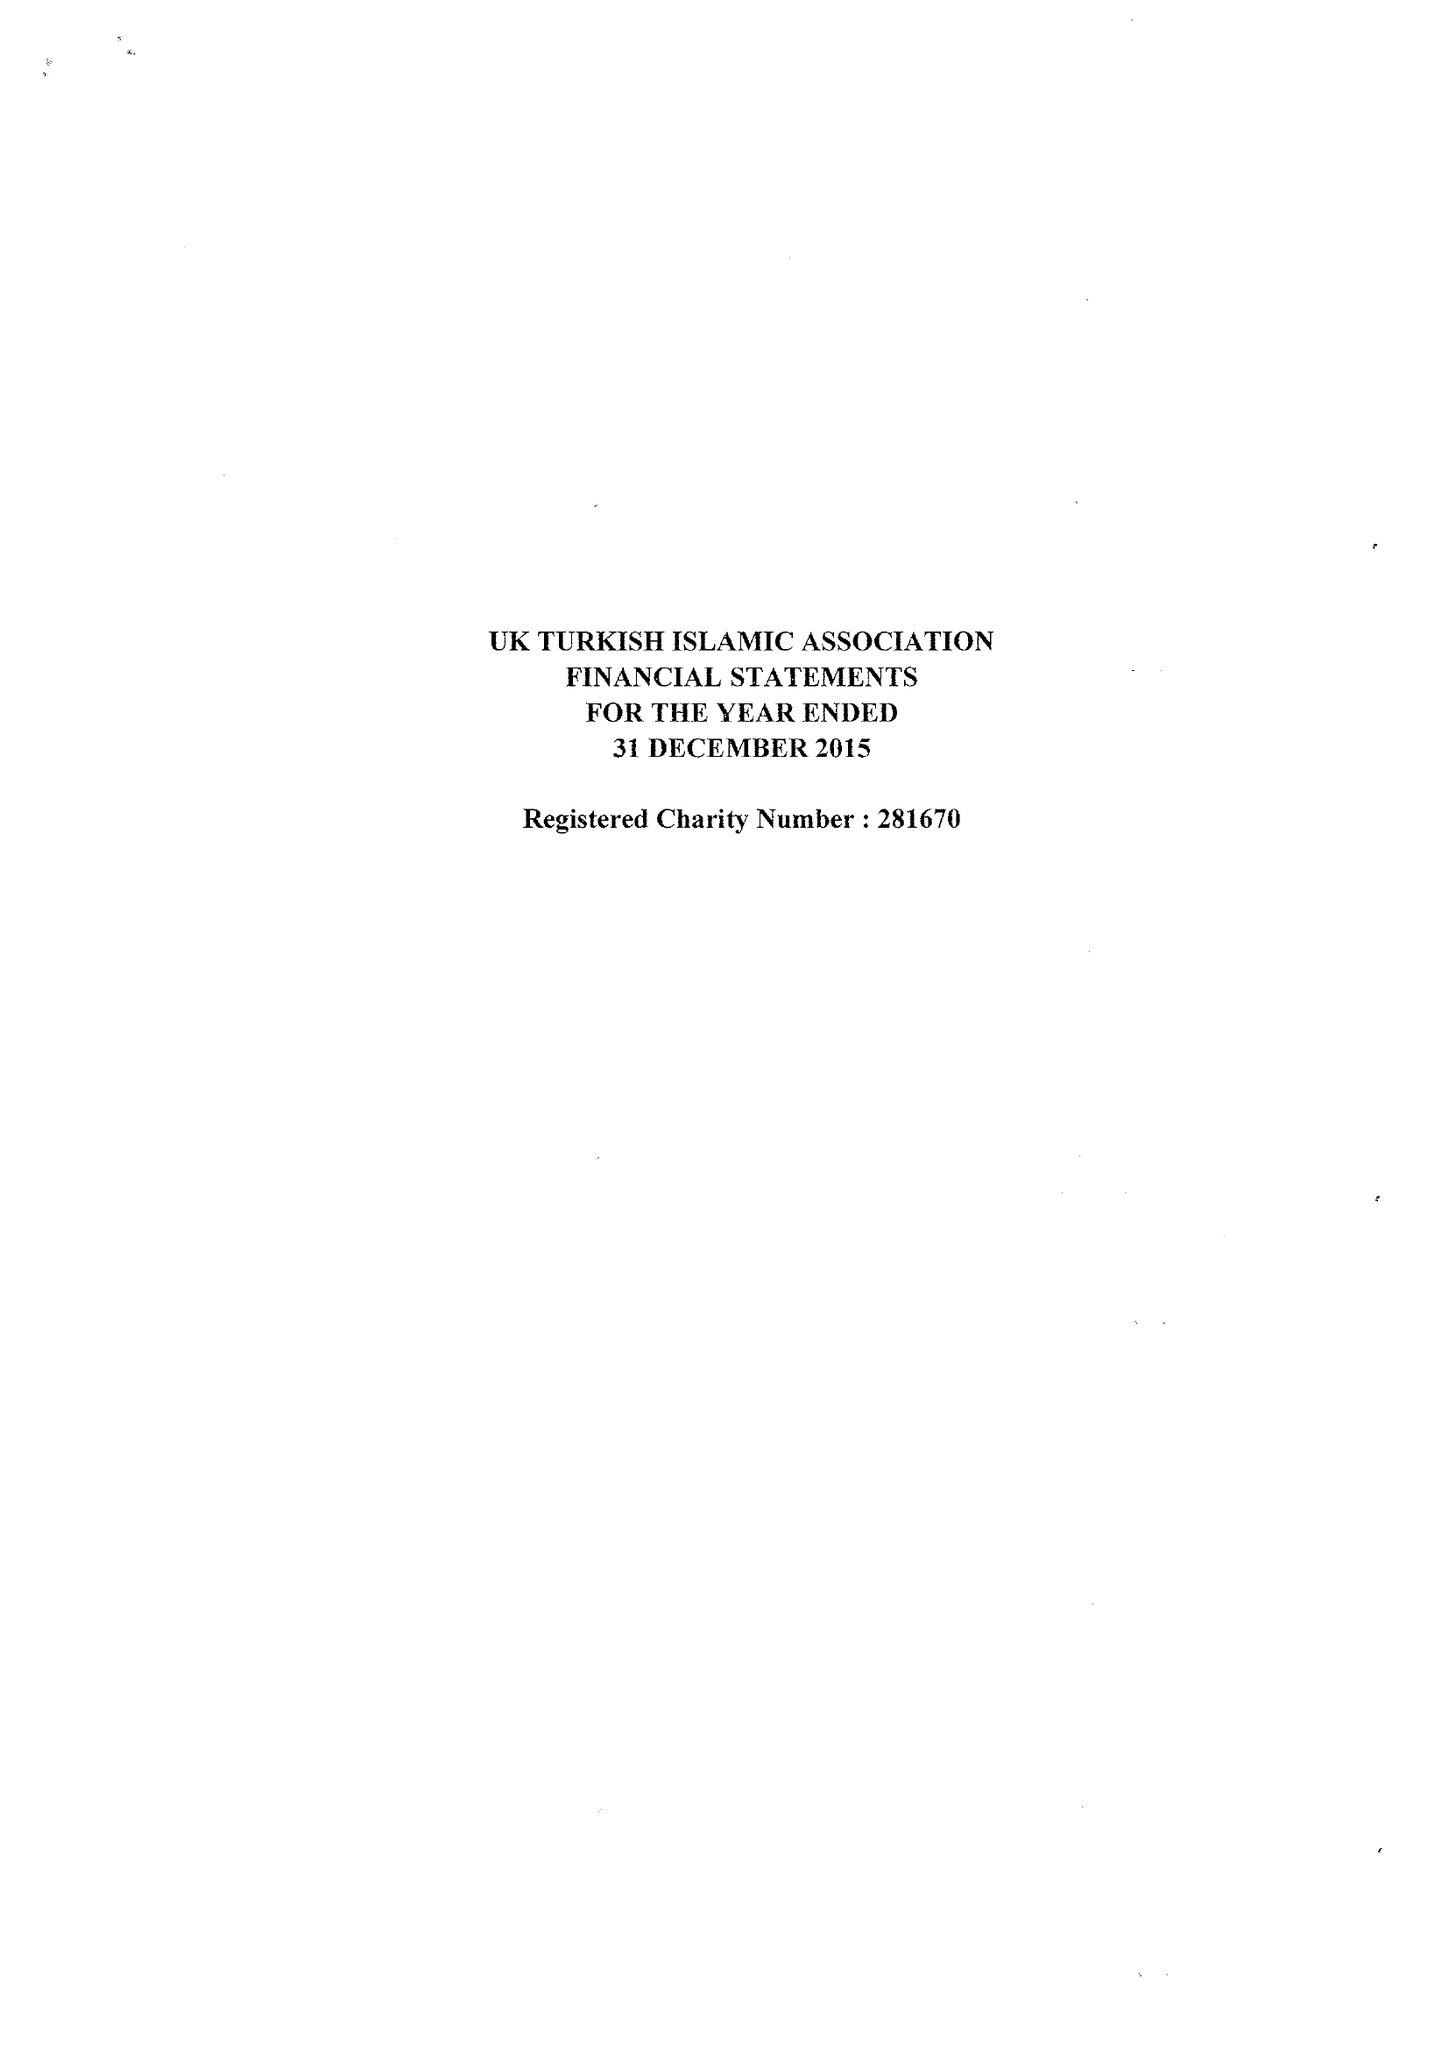What is the value for the spending_annually_in_british_pounds?
Answer the question using a single word or phrase. 126883.00 